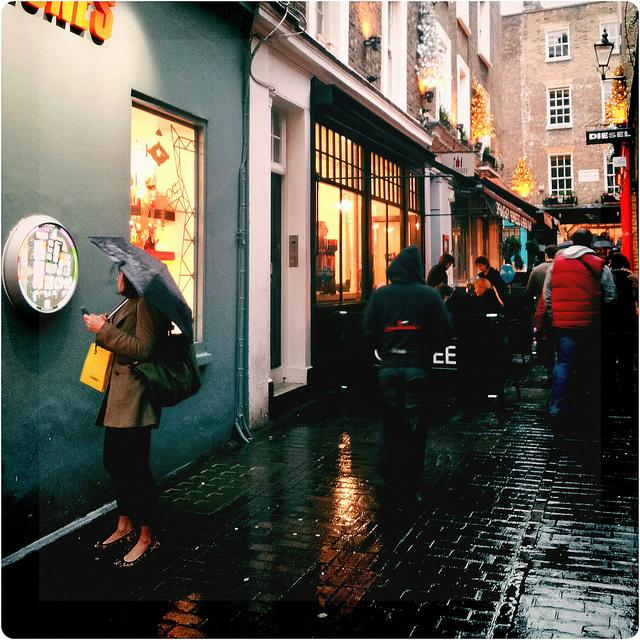What has made the ground shiny? Please explain your reasoning. water. The rain has made the ground wet. 